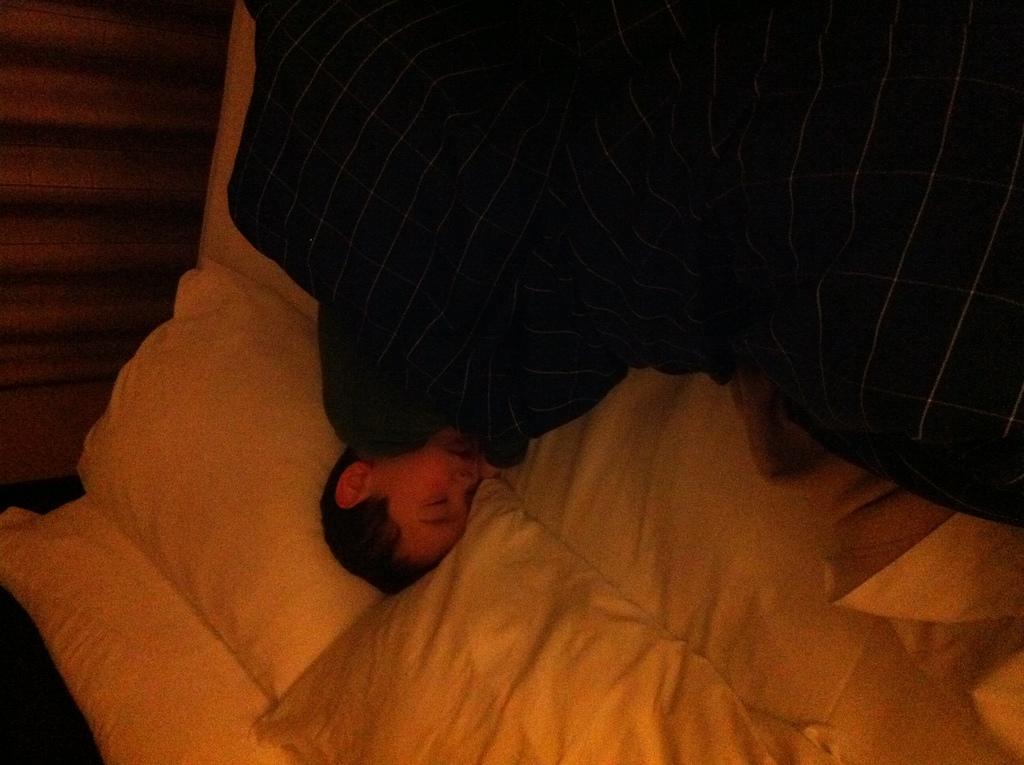How would you summarize this image in a sentence or two? In this image, we can see a person in bed. 